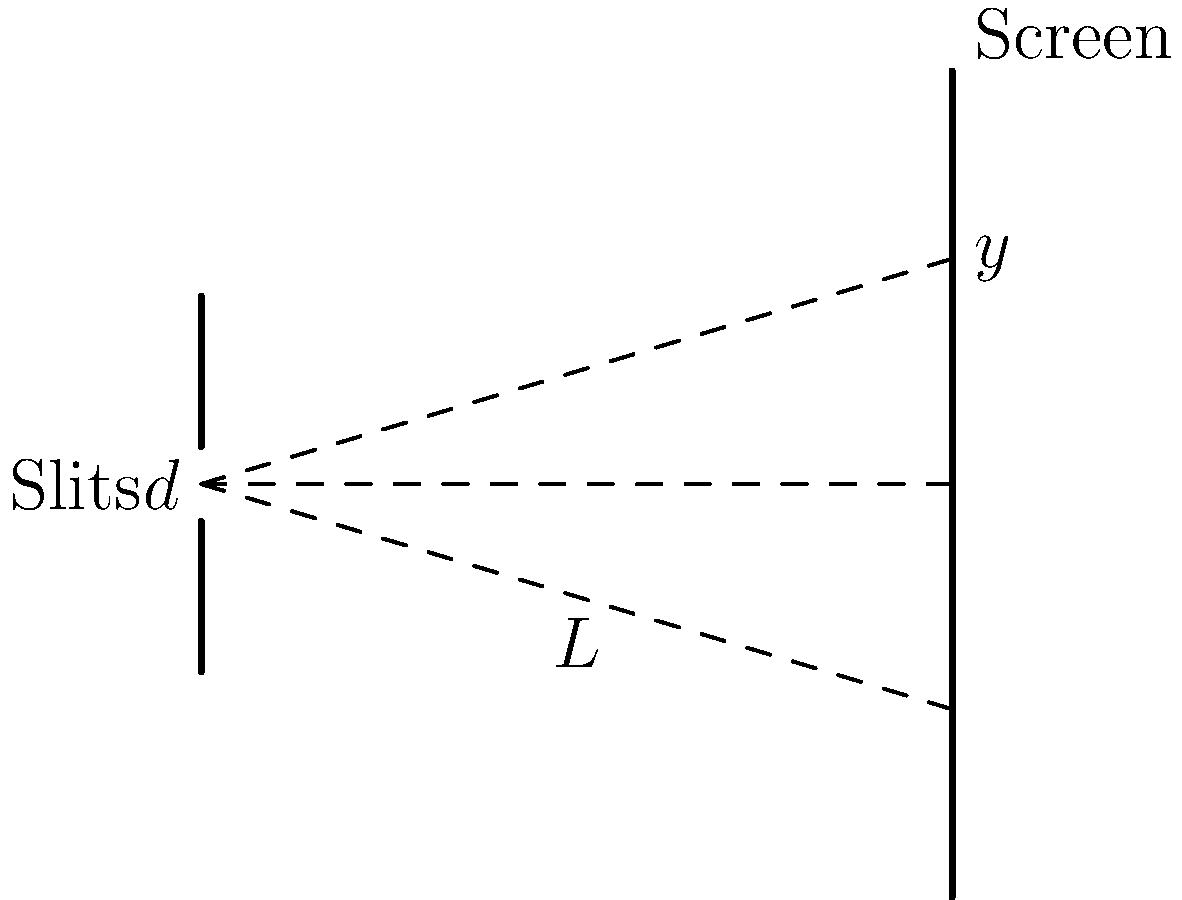In a double-slit interference experiment, two coherent light sources with wavelength $\lambda = 500$ nm are separated by a distance $d = 0.1$ mm. The interference pattern is observed on a screen placed $L = 2$ m away from the slits. Calculate the distance $y$ from the central maximum to the first-order maximum in the interference pattern. To solve this problem, we'll use the equation for the double-slit interference pattern:

$$y = \frac{m\lambda L}{d}$$

Where:
- $y$ is the distance from the central maximum to the m-th order maximum
- $m$ is the order of the maximum (in this case, $m = 1$ for the first-order maximum)
- $\lambda$ is the wavelength of light
- $L$ is the distance from the slits to the screen
- $d$ is the distance between the slits

Step 1: Convert all units to meters
$\lambda = 500 \text{ nm} = 5 \times 10^{-7} \text{ m}$
$d = 0.1 \text{ mm} = 1 \times 10^{-4} \text{ m}$
$L = 2 \text{ m}$

Step 2: Substitute the values into the equation
$$y = \frac{(1)(5 \times 10^{-7} \text{ m})(2 \text{ m})}{1 \times 10^{-4} \text{ m}}$$

Step 3: Calculate the result
$$y = \frac{1 \times 10^{-6}}{1 \times 10^{-4}} = 1 \times 10^{-2} \text{ m} = 0.01 \text{ m} = 1 \text{ cm}$$

Therefore, the distance from the central maximum to the first-order maximum is 1 cm.
Answer: 1 cm 